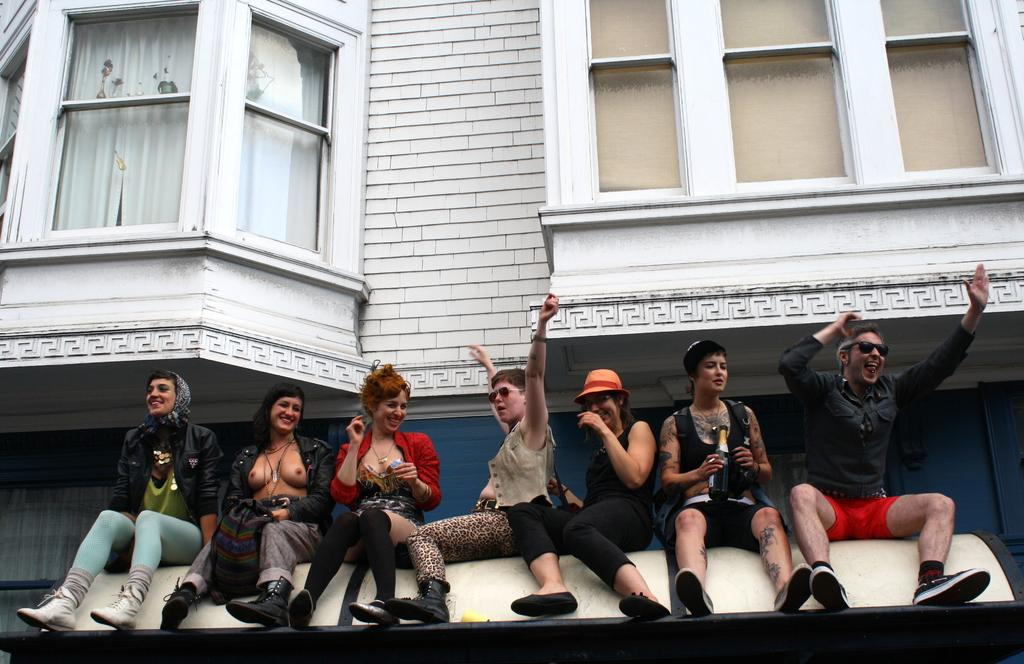What is the main structure in the image? There is a building in the image. What feature can be seen on the building? The building has windows. What are the people at the bottom of the image doing? There are people sitting at the bottom of the image. What object is one person holding? One person is holding a bottle. What type of rail is visible in the image? There is no rail present in the image. How much honey is being consumed by the people in the image? There is no honey visible in the image, and it is not mentioned that the people are consuming honey. 